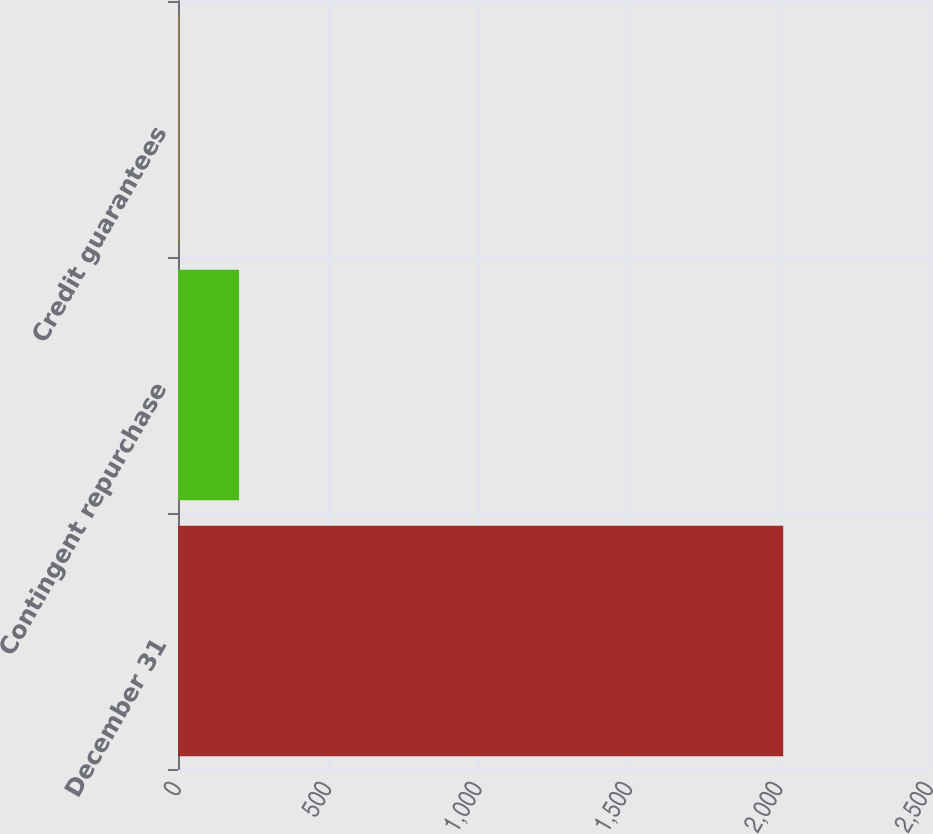Convert chart to OTSL. <chart><loc_0><loc_0><loc_500><loc_500><bar_chart><fcel>December 31<fcel>Contingent repurchase<fcel>Credit guarantees<nl><fcel>2012<fcel>203<fcel>2<nl></chart> 